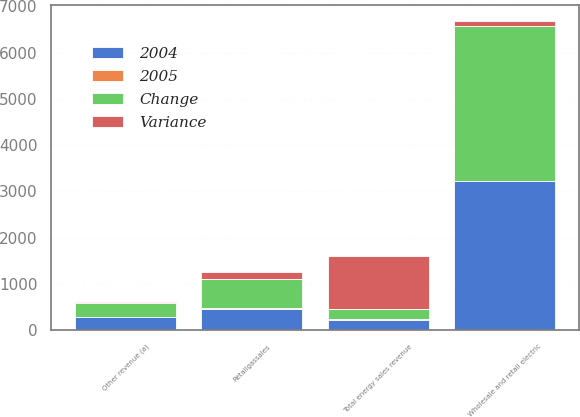<chart> <loc_0><loc_0><loc_500><loc_500><stacked_bar_chart><ecel><fcel>Wholesale and retail electric<fcel>Total energy sales revenue<fcel>Retailgassales<fcel>Other revenue (a)<nl><fcel>Change<fcel>3341<fcel>222<fcel>613<fcel>300<nl><fcel>2004<fcel>3227<fcel>222<fcel>448<fcel>279<nl><fcel>Variance<fcel>114<fcel>1140<fcel>165<fcel>21<nl><fcel>2005<fcel>3.5<fcel>16.3<fcel>36.8<fcel>7.5<nl></chart> 